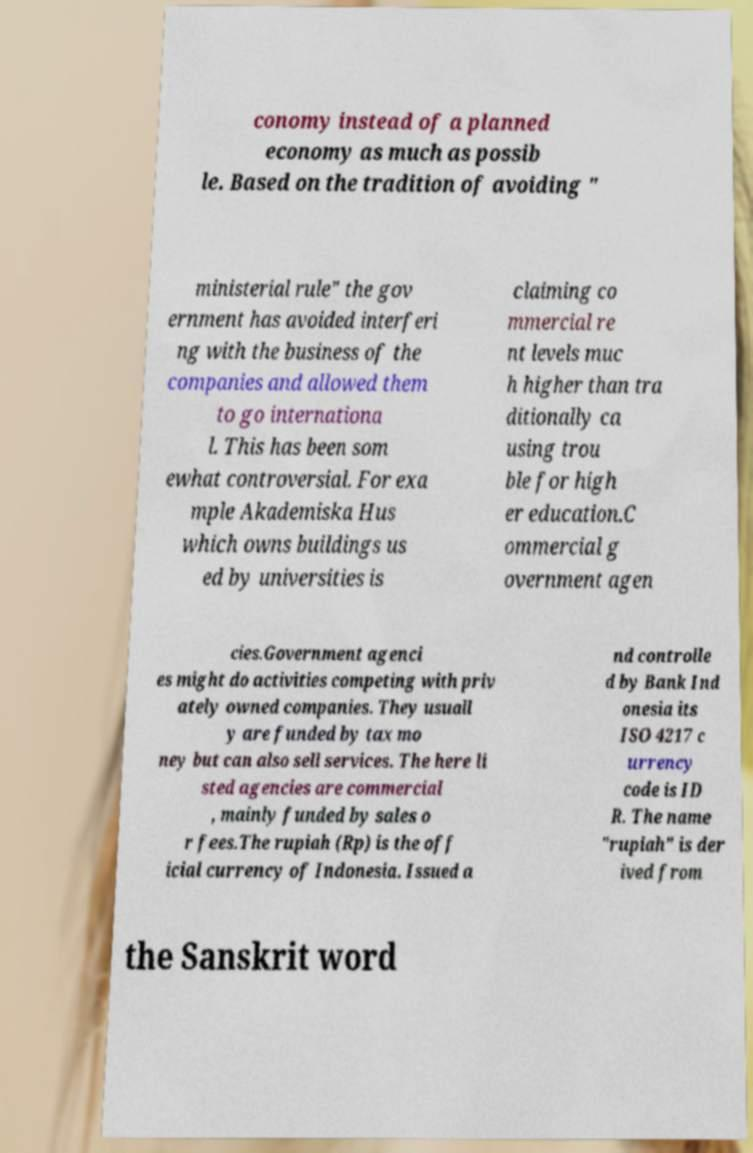Can you accurately transcribe the text from the provided image for me? conomy instead of a planned economy as much as possib le. Based on the tradition of avoiding " ministerial rule" the gov ernment has avoided interferi ng with the business of the companies and allowed them to go internationa l. This has been som ewhat controversial. For exa mple Akademiska Hus which owns buildings us ed by universities is claiming co mmercial re nt levels muc h higher than tra ditionally ca using trou ble for high er education.C ommercial g overnment agen cies.Government agenci es might do activities competing with priv ately owned companies. They usuall y are funded by tax mo ney but can also sell services. The here li sted agencies are commercial , mainly funded by sales o r fees.The rupiah (Rp) is the off icial currency of Indonesia. Issued a nd controlle d by Bank Ind onesia its ISO 4217 c urrency code is ID R. The name "rupiah" is der ived from the Sanskrit word 